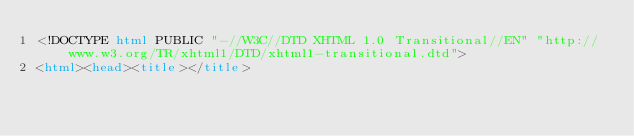Convert code to text. <code><loc_0><loc_0><loc_500><loc_500><_HTML_><!DOCTYPE html PUBLIC "-//W3C//DTD XHTML 1.0 Transitional//EN" "http://www.w3.org/TR/xhtml1/DTD/xhtml1-transitional.dtd">
<html><head><title></title></code> 